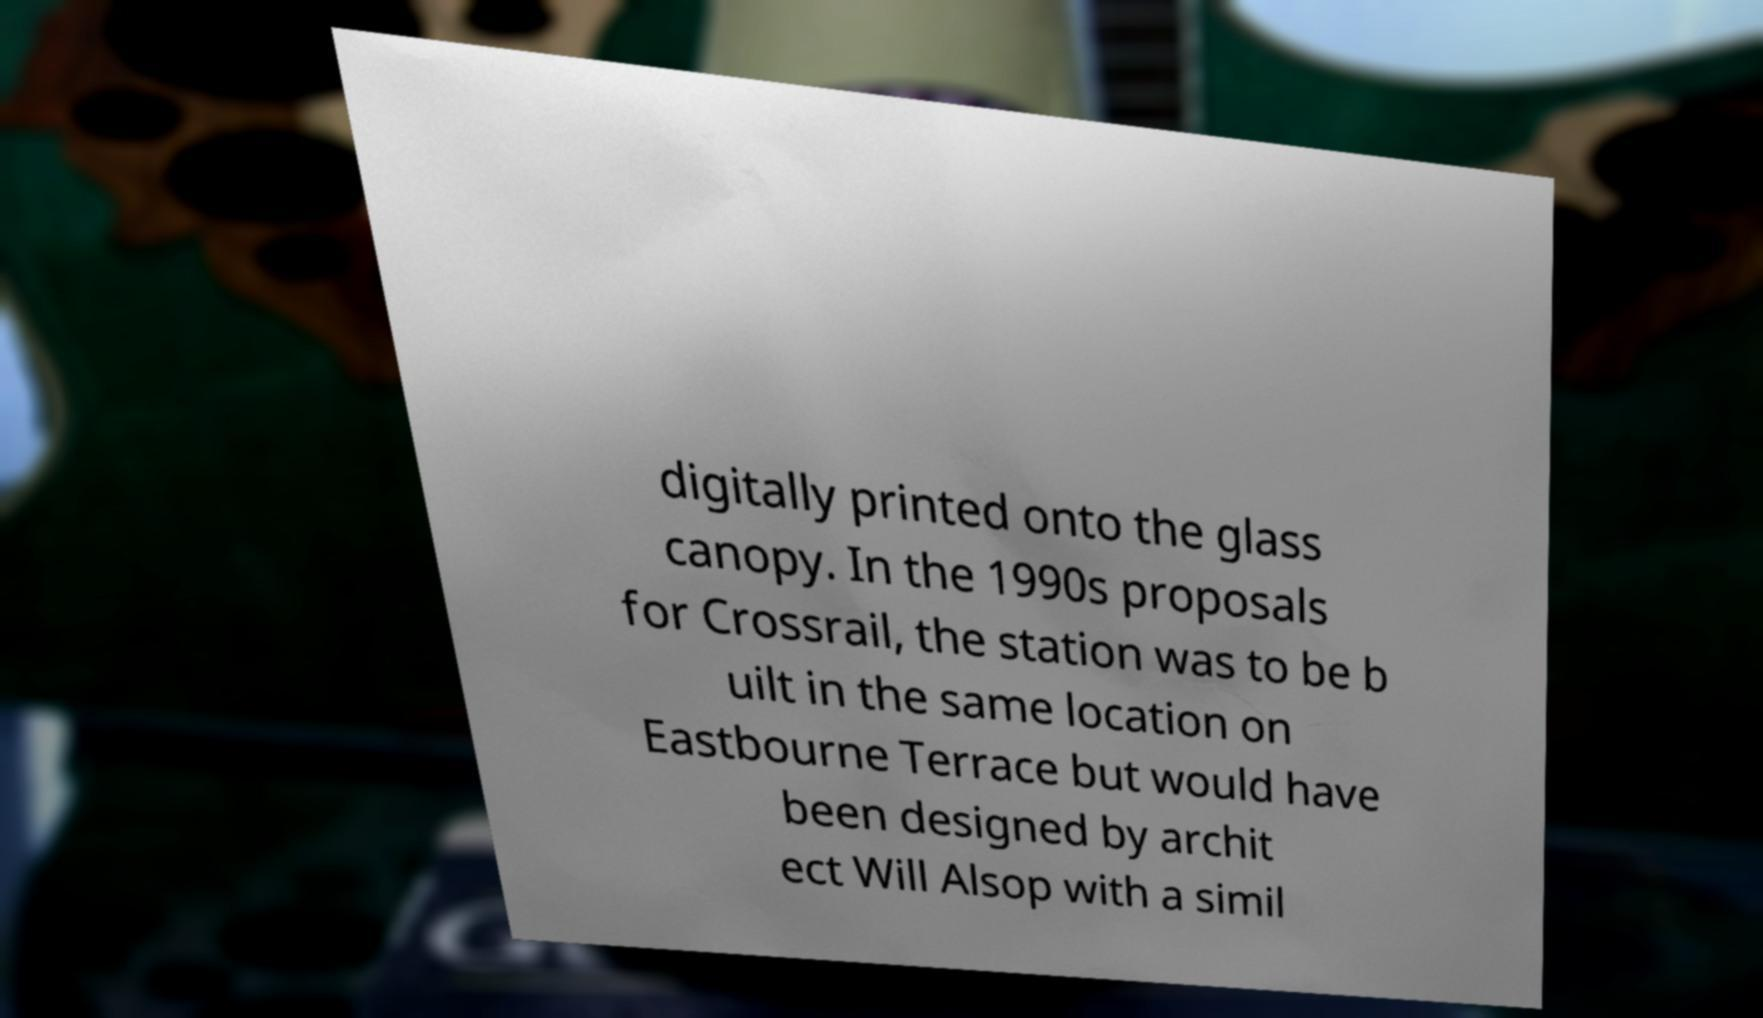Can you read and provide the text displayed in the image?This photo seems to have some interesting text. Can you extract and type it out for me? digitally printed onto the glass canopy. In the 1990s proposals for Crossrail, the station was to be b uilt in the same location on Eastbourne Terrace but would have been designed by archit ect Will Alsop with a simil 